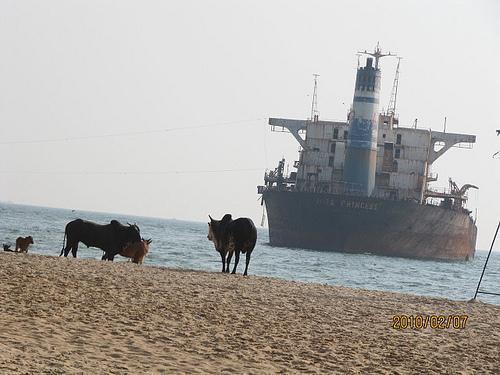How many animals are shown?
Give a very brief answer. 4. 